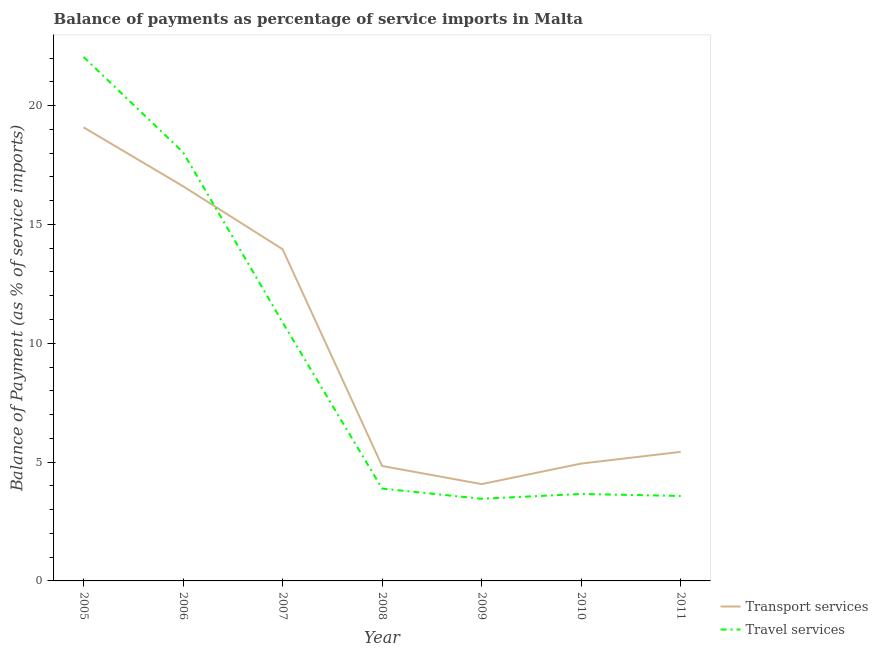How many different coloured lines are there?
Offer a terse response. 2. What is the balance of payments of travel services in 2007?
Keep it short and to the point. 10.88. Across all years, what is the maximum balance of payments of transport services?
Make the answer very short. 19.08. Across all years, what is the minimum balance of payments of transport services?
Offer a very short reply. 4.07. What is the total balance of payments of transport services in the graph?
Ensure brevity in your answer.  68.92. What is the difference between the balance of payments of transport services in 2007 and that in 2008?
Your response must be concise. 9.12. What is the difference between the balance of payments of travel services in 2011 and the balance of payments of transport services in 2005?
Offer a terse response. -15.51. What is the average balance of payments of travel services per year?
Ensure brevity in your answer.  9.36. In the year 2006, what is the difference between the balance of payments of transport services and balance of payments of travel services?
Offer a terse response. -1.43. In how many years, is the balance of payments of transport services greater than 21 %?
Provide a succinct answer. 0. What is the ratio of the balance of payments of travel services in 2010 to that in 2011?
Provide a short and direct response. 1.02. Is the difference between the balance of payments of transport services in 2008 and 2009 greater than the difference between the balance of payments of travel services in 2008 and 2009?
Make the answer very short. Yes. What is the difference between the highest and the second highest balance of payments of transport services?
Your answer should be very brief. 2.48. What is the difference between the highest and the lowest balance of payments of transport services?
Provide a short and direct response. 15.01. Is the sum of the balance of payments of travel services in 2005 and 2008 greater than the maximum balance of payments of transport services across all years?
Provide a short and direct response. Yes. Does the balance of payments of travel services monotonically increase over the years?
Offer a very short reply. No. Is the balance of payments of transport services strictly less than the balance of payments of travel services over the years?
Provide a succinct answer. No. What is the difference between two consecutive major ticks on the Y-axis?
Provide a succinct answer. 5. Are the values on the major ticks of Y-axis written in scientific E-notation?
Provide a short and direct response. No. Where does the legend appear in the graph?
Your answer should be compact. Bottom right. What is the title of the graph?
Give a very brief answer. Balance of payments as percentage of service imports in Malta. What is the label or title of the Y-axis?
Offer a very short reply. Balance of Payment (as % of service imports). What is the Balance of Payment (as % of service imports) in Transport services in 2005?
Keep it short and to the point. 19.08. What is the Balance of Payment (as % of service imports) in Travel services in 2005?
Your response must be concise. 22.05. What is the Balance of Payment (as % of service imports) of Transport services in 2006?
Your answer should be compact. 16.61. What is the Balance of Payment (as % of service imports) of Travel services in 2006?
Provide a succinct answer. 18.03. What is the Balance of Payment (as % of service imports) in Transport services in 2007?
Give a very brief answer. 13.96. What is the Balance of Payment (as % of service imports) of Travel services in 2007?
Give a very brief answer. 10.88. What is the Balance of Payment (as % of service imports) in Transport services in 2008?
Your response must be concise. 4.84. What is the Balance of Payment (as % of service imports) of Travel services in 2008?
Your answer should be compact. 3.88. What is the Balance of Payment (as % of service imports) in Transport services in 2009?
Ensure brevity in your answer.  4.07. What is the Balance of Payment (as % of service imports) of Travel services in 2009?
Your response must be concise. 3.46. What is the Balance of Payment (as % of service imports) in Transport services in 2010?
Offer a very short reply. 4.94. What is the Balance of Payment (as % of service imports) of Travel services in 2010?
Offer a very short reply. 3.66. What is the Balance of Payment (as % of service imports) in Transport services in 2011?
Provide a succinct answer. 5.43. What is the Balance of Payment (as % of service imports) in Travel services in 2011?
Offer a very short reply. 3.57. Across all years, what is the maximum Balance of Payment (as % of service imports) in Transport services?
Offer a terse response. 19.08. Across all years, what is the maximum Balance of Payment (as % of service imports) of Travel services?
Keep it short and to the point. 22.05. Across all years, what is the minimum Balance of Payment (as % of service imports) in Transport services?
Give a very brief answer. 4.07. Across all years, what is the minimum Balance of Payment (as % of service imports) of Travel services?
Offer a very short reply. 3.46. What is the total Balance of Payment (as % of service imports) in Transport services in the graph?
Your answer should be compact. 68.92. What is the total Balance of Payment (as % of service imports) in Travel services in the graph?
Offer a very short reply. 65.53. What is the difference between the Balance of Payment (as % of service imports) of Transport services in 2005 and that in 2006?
Your answer should be compact. 2.48. What is the difference between the Balance of Payment (as % of service imports) in Travel services in 2005 and that in 2006?
Provide a succinct answer. 4.01. What is the difference between the Balance of Payment (as % of service imports) in Transport services in 2005 and that in 2007?
Offer a terse response. 5.13. What is the difference between the Balance of Payment (as % of service imports) of Travel services in 2005 and that in 2007?
Your answer should be compact. 11.17. What is the difference between the Balance of Payment (as % of service imports) of Transport services in 2005 and that in 2008?
Offer a terse response. 14.25. What is the difference between the Balance of Payment (as % of service imports) in Travel services in 2005 and that in 2008?
Your response must be concise. 18.16. What is the difference between the Balance of Payment (as % of service imports) of Transport services in 2005 and that in 2009?
Provide a succinct answer. 15.01. What is the difference between the Balance of Payment (as % of service imports) of Travel services in 2005 and that in 2009?
Make the answer very short. 18.59. What is the difference between the Balance of Payment (as % of service imports) of Transport services in 2005 and that in 2010?
Provide a succinct answer. 14.15. What is the difference between the Balance of Payment (as % of service imports) of Travel services in 2005 and that in 2010?
Provide a short and direct response. 18.39. What is the difference between the Balance of Payment (as % of service imports) in Transport services in 2005 and that in 2011?
Give a very brief answer. 13.65. What is the difference between the Balance of Payment (as % of service imports) in Travel services in 2005 and that in 2011?
Your answer should be compact. 18.47. What is the difference between the Balance of Payment (as % of service imports) of Transport services in 2006 and that in 2007?
Keep it short and to the point. 2.65. What is the difference between the Balance of Payment (as % of service imports) in Travel services in 2006 and that in 2007?
Give a very brief answer. 7.16. What is the difference between the Balance of Payment (as % of service imports) of Transport services in 2006 and that in 2008?
Ensure brevity in your answer.  11.77. What is the difference between the Balance of Payment (as % of service imports) of Travel services in 2006 and that in 2008?
Provide a short and direct response. 14.15. What is the difference between the Balance of Payment (as % of service imports) of Transport services in 2006 and that in 2009?
Ensure brevity in your answer.  12.53. What is the difference between the Balance of Payment (as % of service imports) of Travel services in 2006 and that in 2009?
Your answer should be very brief. 14.58. What is the difference between the Balance of Payment (as % of service imports) of Transport services in 2006 and that in 2010?
Offer a very short reply. 11.67. What is the difference between the Balance of Payment (as % of service imports) in Travel services in 2006 and that in 2010?
Make the answer very short. 14.37. What is the difference between the Balance of Payment (as % of service imports) of Transport services in 2006 and that in 2011?
Your answer should be very brief. 11.18. What is the difference between the Balance of Payment (as % of service imports) of Travel services in 2006 and that in 2011?
Your response must be concise. 14.46. What is the difference between the Balance of Payment (as % of service imports) of Transport services in 2007 and that in 2008?
Make the answer very short. 9.12. What is the difference between the Balance of Payment (as % of service imports) in Travel services in 2007 and that in 2008?
Provide a short and direct response. 6.99. What is the difference between the Balance of Payment (as % of service imports) of Transport services in 2007 and that in 2009?
Provide a short and direct response. 9.88. What is the difference between the Balance of Payment (as % of service imports) of Travel services in 2007 and that in 2009?
Ensure brevity in your answer.  7.42. What is the difference between the Balance of Payment (as % of service imports) of Transport services in 2007 and that in 2010?
Your answer should be compact. 9.02. What is the difference between the Balance of Payment (as % of service imports) in Travel services in 2007 and that in 2010?
Make the answer very short. 7.22. What is the difference between the Balance of Payment (as % of service imports) of Transport services in 2007 and that in 2011?
Provide a short and direct response. 8.53. What is the difference between the Balance of Payment (as % of service imports) of Travel services in 2007 and that in 2011?
Give a very brief answer. 7.3. What is the difference between the Balance of Payment (as % of service imports) of Transport services in 2008 and that in 2009?
Your answer should be very brief. 0.76. What is the difference between the Balance of Payment (as % of service imports) in Travel services in 2008 and that in 2009?
Your answer should be compact. 0.43. What is the difference between the Balance of Payment (as % of service imports) in Transport services in 2008 and that in 2010?
Make the answer very short. -0.1. What is the difference between the Balance of Payment (as % of service imports) of Travel services in 2008 and that in 2010?
Offer a terse response. 0.22. What is the difference between the Balance of Payment (as % of service imports) of Transport services in 2008 and that in 2011?
Ensure brevity in your answer.  -0.59. What is the difference between the Balance of Payment (as % of service imports) of Travel services in 2008 and that in 2011?
Provide a succinct answer. 0.31. What is the difference between the Balance of Payment (as % of service imports) in Transport services in 2009 and that in 2010?
Your response must be concise. -0.86. What is the difference between the Balance of Payment (as % of service imports) of Travel services in 2009 and that in 2010?
Provide a succinct answer. -0.2. What is the difference between the Balance of Payment (as % of service imports) of Transport services in 2009 and that in 2011?
Ensure brevity in your answer.  -1.36. What is the difference between the Balance of Payment (as % of service imports) of Travel services in 2009 and that in 2011?
Your response must be concise. -0.12. What is the difference between the Balance of Payment (as % of service imports) in Transport services in 2010 and that in 2011?
Provide a short and direct response. -0.49. What is the difference between the Balance of Payment (as % of service imports) of Travel services in 2010 and that in 2011?
Make the answer very short. 0.09. What is the difference between the Balance of Payment (as % of service imports) of Transport services in 2005 and the Balance of Payment (as % of service imports) of Travel services in 2006?
Offer a very short reply. 1.05. What is the difference between the Balance of Payment (as % of service imports) of Transport services in 2005 and the Balance of Payment (as % of service imports) of Travel services in 2007?
Your answer should be very brief. 8.21. What is the difference between the Balance of Payment (as % of service imports) of Transport services in 2005 and the Balance of Payment (as % of service imports) of Travel services in 2008?
Your answer should be very brief. 15.2. What is the difference between the Balance of Payment (as % of service imports) of Transport services in 2005 and the Balance of Payment (as % of service imports) of Travel services in 2009?
Make the answer very short. 15.63. What is the difference between the Balance of Payment (as % of service imports) in Transport services in 2005 and the Balance of Payment (as % of service imports) in Travel services in 2010?
Offer a terse response. 15.42. What is the difference between the Balance of Payment (as % of service imports) in Transport services in 2005 and the Balance of Payment (as % of service imports) in Travel services in 2011?
Provide a short and direct response. 15.51. What is the difference between the Balance of Payment (as % of service imports) of Transport services in 2006 and the Balance of Payment (as % of service imports) of Travel services in 2007?
Ensure brevity in your answer.  5.73. What is the difference between the Balance of Payment (as % of service imports) of Transport services in 2006 and the Balance of Payment (as % of service imports) of Travel services in 2008?
Your answer should be compact. 12.72. What is the difference between the Balance of Payment (as % of service imports) of Transport services in 2006 and the Balance of Payment (as % of service imports) of Travel services in 2009?
Provide a succinct answer. 13.15. What is the difference between the Balance of Payment (as % of service imports) in Transport services in 2006 and the Balance of Payment (as % of service imports) in Travel services in 2010?
Keep it short and to the point. 12.95. What is the difference between the Balance of Payment (as % of service imports) of Transport services in 2006 and the Balance of Payment (as % of service imports) of Travel services in 2011?
Your response must be concise. 13.03. What is the difference between the Balance of Payment (as % of service imports) in Transport services in 2007 and the Balance of Payment (as % of service imports) in Travel services in 2008?
Make the answer very short. 10.07. What is the difference between the Balance of Payment (as % of service imports) of Transport services in 2007 and the Balance of Payment (as % of service imports) of Travel services in 2009?
Your response must be concise. 10.5. What is the difference between the Balance of Payment (as % of service imports) in Transport services in 2007 and the Balance of Payment (as % of service imports) in Travel services in 2010?
Ensure brevity in your answer.  10.3. What is the difference between the Balance of Payment (as % of service imports) in Transport services in 2007 and the Balance of Payment (as % of service imports) in Travel services in 2011?
Your response must be concise. 10.38. What is the difference between the Balance of Payment (as % of service imports) in Transport services in 2008 and the Balance of Payment (as % of service imports) in Travel services in 2009?
Provide a succinct answer. 1.38. What is the difference between the Balance of Payment (as % of service imports) of Transport services in 2008 and the Balance of Payment (as % of service imports) of Travel services in 2010?
Give a very brief answer. 1.18. What is the difference between the Balance of Payment (as % of service imports) in Transport services in 2008 and the Balance of Payment (as % of service imports) in Travel services in 2011?
Offer a very short reply. 1.26. What is the difference between the Balance of Payment (as % of service imports) in Transport services in 2009 and the Balance of Payment (as % of service imports) in Travel services in 2010?
Keep it short and to the point. 0.41. What is the difference between the Balance of Payment (as % of service imports) in Transport services in 2009 and the Balance of Payment (as % of service imports) in Travel services in 2011?
Provide a succinct answer. 0.5. What is the difference between the Balance of Payment (as % of service imports) of Transport services in 2010 and the Balance of Payment (as % of service imports) of Travel services in 2011?
Keep it short and to the point. 1.36. What is the average Balance of Payment (as % of service imports) of Transport services per year?
Make the answer very short. 9.85. What is the average Balance of Payment (as % of service imports) in Travel services per year?
Make the answer very short. 9.36. In the year 2005, what is the difference between the Balance of Payment (as % of service imports) in Transport services and Balance of Payment (as % of service imports) in Travel services?
Your answer should be very brief. -2.96. In the year 2006, what is the difference between the Balance of Payment (as % of service imports) of Transport services and Balance of Payment (as % of service imports) of Travel services?
Keep it short and to the point. -1.43. In the year 2007, what is the difference between the Balance of Payment (as % of service imports) of Transport services and Balance of Payment (as % of service imports) of Travel services?
Keep it short and to the point. 3.08. In the year 2008, what is the difference between the Balance of Payment (as % of service imports) in Transport services and Balance of Payment (as % of service imports) in Travel services?
Ensure brevity in your answer.  0.95. In the year 2009, what is the difference between the Balance of Payment (as % of service imports) of Transport services and Balance of Payment (as % of service imports) of Travel services?
Make the answer very short. 0.62. In the year 2010, what is the difference between the Balance of Payment (as % of service imports) of Transport services and Balance of Payment (as % of service imports) of Travel services?
Your answer should be very brief. 1.28. In the year 2011, what is the difference between the Balance of Payment (as % of service imports) in Transport services and Balance of Payment (as % of service imports) in Travel services?
Your answer should be very brief. 1.86. What is the ratio of the Balance of Payment (as % of service imports) of Transport services in 2005 to that in 2006?
Offer a very short reply. 1.15. What is the ratio of the Balance of Payment (as % of service imports) in Travel services in 2005 to that in 2006?
Your answer should be very brief. 1.22. What is the ratio of the Balance of Payment (as % of service imports) in Transport services in 2005 to that in 2007?
Provide a succinct answer. 1.37. What is the ratio of the Balance of Payment (as % of service imports) in Travel services in 2005 to that in 2007?
Offer a terse response. 2.03. What is the ratio of the Balance of Payment (as % of service imports) in Transport services in 2005 to that in 2008?
Offer a very short reply. 3.95. What is the ratio of the Balance of Payment (as % of service imports) of Travel services in 2005 to that in 2008?
Give a very brief answer. 5.68. What is the ratio of the Balance of Payment (as % of service imports) in Transport services in 2005 to that in 2009?
Offer a very short reply. 4.68. What is the ratio of the Balance of Payment (as % of service imports) in Travel services in 2005 to that in 2009?
Your answer should be very brief. 6.38. What is the ratio of the Balance of Payment (as % of service imports) of Transport services in 2005 to that in 2010?
Provide a succinct answer. 3.86. What is the ratio of the Balance of Payment (as % of service imports) of Travel services in 2005 to that in 2010?
Provide a succinct answer. 6.02. What is the ratio of the Balance of Payment (as % of service imports) in Transport services in 2005 to that in 2011?
Offer a terse response. 3.51. What is the ratio of the Balance of Payment (as % of service imports) of Travel services in 2005 to that in 2011?
Give a very brief answer. 6.17. What is the ratio of the Balance of Payment (as % of service imports) in Transport services in 2006 to that in 2007?
Provide a short and direct response. 1.19. What is the ratio of the Balance of Payment (as % of service imports) of Travel services in 2006 to that in 2007?
Make the answer very short. 1.66. What is the ratio of the Balance of Payment (as % of service imports) in Transport services in 2006 to that in 2008?
Your response must be concise. 3.43. What is the ratio of the Balance of Payment (as % of service imports) of Travel services in 2006 to that in 2008?
Ensure brevity in your answer.  4.64. What is the ratio of the Balance of Payment (as % of service imports) in Transport services in 2006 to that in 2009?
Give a very brief answer. 4.08. What is the ratio of the Balance of Payment (as % of service imports) in Travel services in 2006 to that in 2009?
Your answer should be very brief. 5.22. What is the ratio of the Balance of Payment (as % of service imports) in Transport services in 2006 to that in 2010?
Your answer should be very brief. 3.36. What is the ratio of the Balance of Payment (as % of service imports) in Travel services in 2006 to that in 2010?
Offer a very short reply. 4.93. What is the ratio of the Balance of Payment (as % of service imports) in Transport services in 2006 to that in 2011?
Make the answer very short. 3.06. What is the ratio of the Balance of Payment (as % of service imports) of Travel services in 2006 to that in 2011?
Your answer should be very brief. 5.05. What is the ratio of the Balance of Payment (as % of service imports) of Transport services in 2007 to that in 2008?
Your answer should be compact. 2.89. What is the ratio of the Balance of Payment (as % of service imports) in Travel services in 2007 to that in 2008?
Provide a short and direct response. 2.8. What is the ratio of the Balance of Payment (as % of service imports) of Transport services in 2007 to that in 2009?
Provide a short and direct response. 3.43. What is the ratio of the Balance of Payment (as % of service imports) in Travel services in 2007 to that in 2009?
Your answer should be very brief. 3.15. What is the ratio of the Balance of Payment (as % of service imports) of Transport services in 2007 to that in 2010?
Your response must be concise. 2.83. What is the ratio of the Balance of Payment (as % of service imports) of Travel services in 2007 to that in 2010?
Provide a short and direct response. 2.97. What is the ratio of the Balance of Payment (as % of service imports) of Transport services in 2007 to that in 2011?
Your response must be concise. 2.57. What is the ratio of the Balance of Payment (as % of service imports) in Travel services in 2007 to that in 2011?
Your answer should be very brief. 3.04. What is the ratio of the Balance of Payment (as % of service imports) in Transport services in 2008 to that in 2009?
Make the answer very short. 1.19. What is the ratio of the Balance of Payment (as % of service imports) of Travel services in 2008 to that in 2009?
Keep it short and to the point. 1.12. What is the ratio of the Balance of Payment (as % of service imports) in Transport services in 2008 to that in 2010?
Offer a terse response. 0.98. What is the ratio of the Balance of Payment (as % of service imports) in Travel services in 2008 to that in 2010?
Give a very brief answer. 1.06. What is the ratio of the Balance of Payment (as % of service imports) of Transport services in 2008 to that in 2011?
Offer a terse response. 0.89. What is the ratio of the Balance of Payment (as % of service imports) of Travel services in 2008 to that in 2011?
Your answer should be very brief. 1.09. What is the ratio of the Balance of Payment (as % of service imports) in Transport services in 2009 to that in 2010?
Make the answer very short. 0.82. What is the ratio of the Balance of Payment (as % of service imports) of Travel services in 2009 to that in 2010?
Make the answer very short. 0.94. What is the ratio of the Balance of Payment (as % of service imports) of Transport services in 2009 to that in 2011?
Provide a short and direct response. 0.75. What is the ratio of the Balance of Payment (as % of service imports) in Travel services in 2009 to that in 2011?
Make the answer very short. 0.97. What is the ratio of the Balance of Payment (as % of service imports) in Transport services in 2010 to that in 2011?
Make the answer very short. 0.91. What is the ratio of the Balance of Payment (as % of service imports) of Travel services in 2010 to that in 2011?
Your answer should be very brief. 1.02. What is the difference between the highest and the second highest Balance of Payment (as % of service imports) in Transport services?
Give a very brief answer. 2.48. What is the difference between the highest and the second highest Balance of Payment (as % of service imports) of Travel services?
Provide a succinct answer. 4.01. What is the difference between the highest and the lowest Balance of Payment (as % of service imports) of Transport services?
Your answer should be very brief. 15.01. What is the difference between the highest and the lowest Balance of Payment (as % of service imports) in Travel services?
Offer a very short reply. 18.59. 